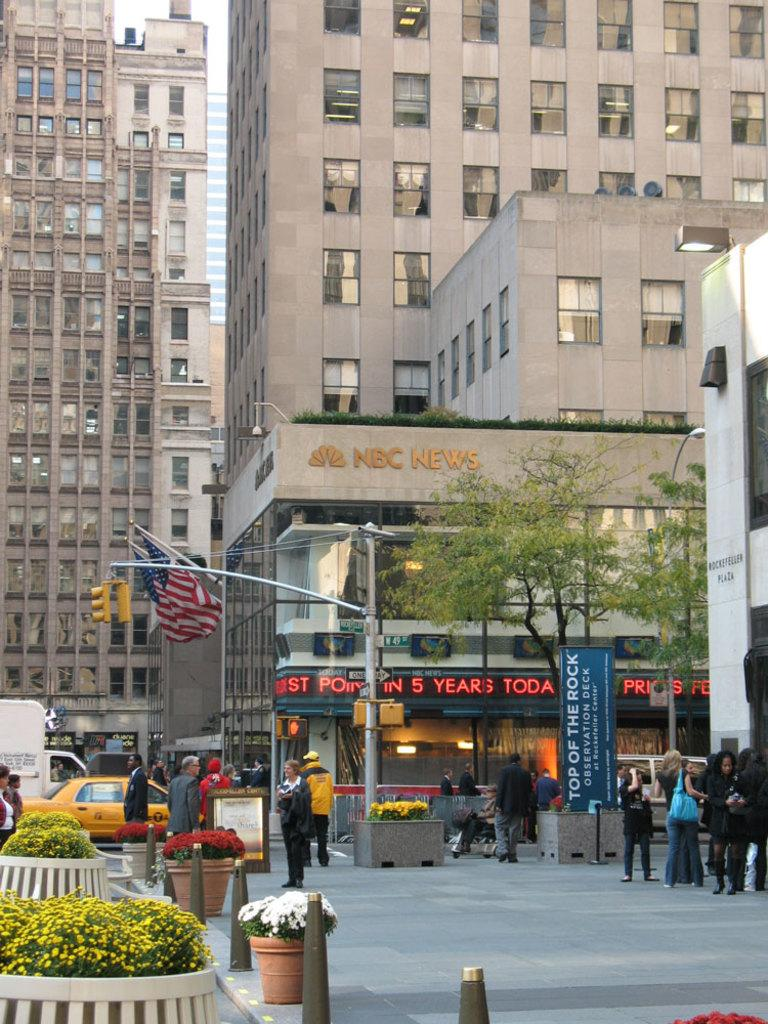<image>
Give a short and clear explanation of the subsequent image. An NBC News building with an American flag hanging off the side. 